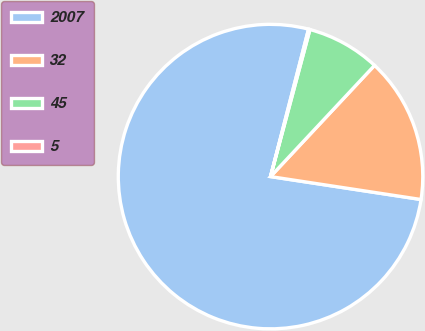Convert chart to OTSL. <chart><loc_0><loc_0><loc_500><loc_500><pie_chart><fcel>2007<fcel>32<fcel>45<fcel>5<nl><fcel>76.61%<fcel>15.44%<fcel>7.8%<fcel>0.15%<nl></chart> 